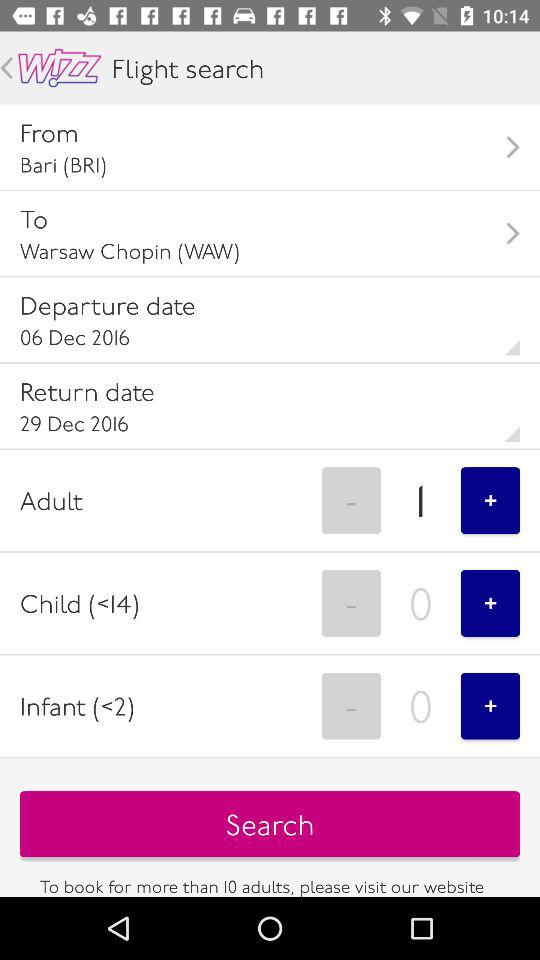The flight takes off from which place? The flight takes off from Bari (BRI). 